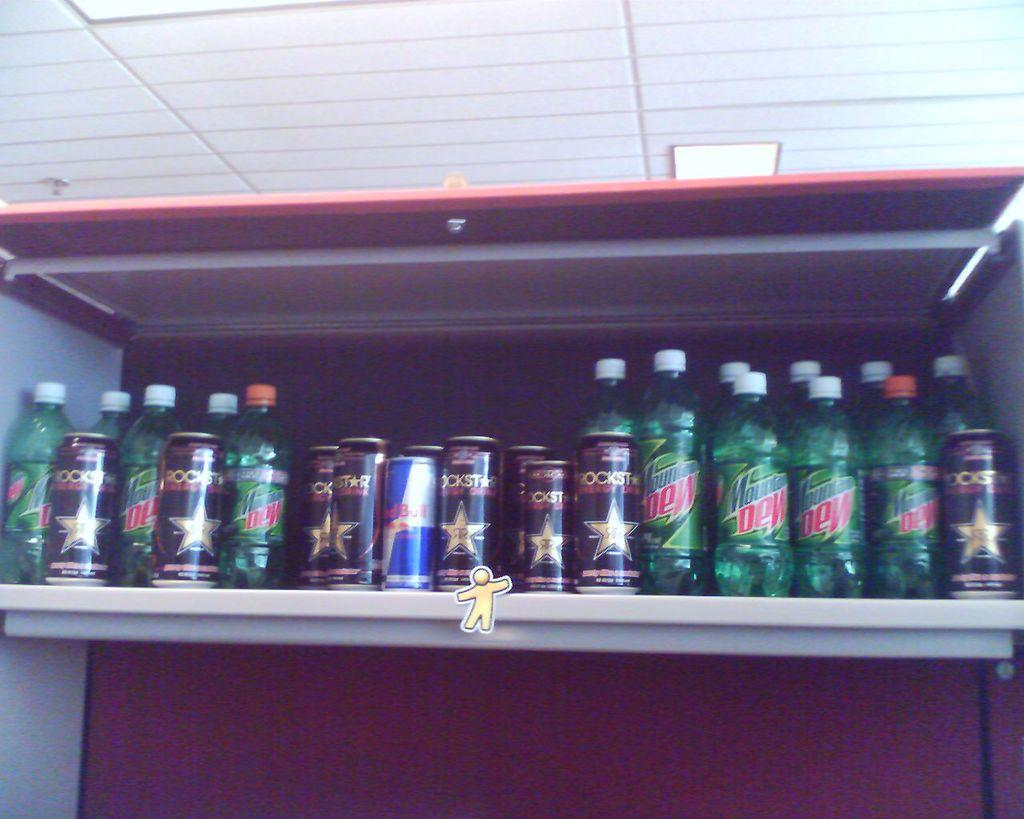<image>
Present a compact description of the photo's key features. a shelf full of cans and bottles of mountain dew and red bull 